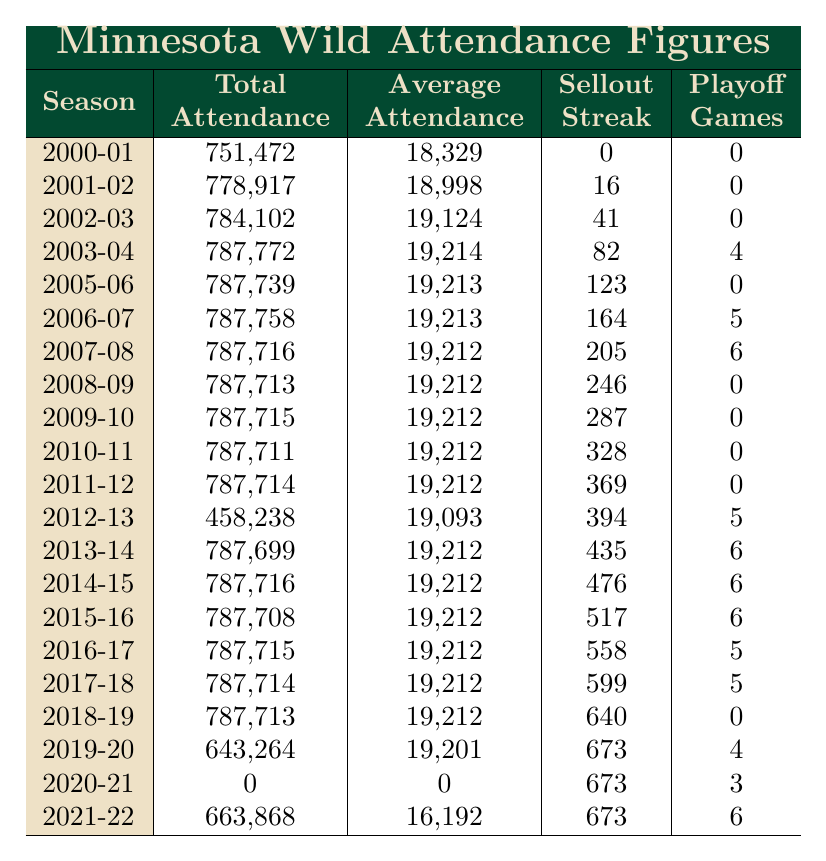What was the total attendance in the 2019-20 season? The table shows that the total attendance for the 2019-20 season was listed as 643,264.
Answer: 643,264 Which season had the highest average attendance? By looking through the Average Attendance column, the highest value is 19,214, which occurred in the seasons: 2003-04, 2005-06, 2006-07, 2007-08, 2008-09, 2009-10, 2010-11, 2011-12, 2013-14, 2014-15, 2015-16, 2016-17, 2017-18, and 2018-19.
Answer: 19,214 Did the Minnesota Wild have any sellout streaks during the 2020-21 season? According to the Sellout Streak column, the value for the 2020-21 season is 673, which indicates a significant sellout streak, but there was actually no attendance due to pandemic restrictions.
Answer: No What is the difference in total attendance between the 2000-01 season and the 2021-22 season? The total attendance for the 2000-01 season is 751,472 and for the 2021-22 season, it is 663,868. The difference is calculated as 751,472 - 663,868 = 87,604.
Answer: 87,604 How many seasons had an average attendance of 19,212? By scanning the Average Attendance column, the value 19,212 appears in the following seasons: 2007-08, 2008-09, 2009-10, 2010-11, 2011-12, 2013-14, 2014-15, 2015-16, 2016-17, 2017-18, and 2018-19. There are 11 seasons in total.
Answer: 11 What was the total attendance for the 2012-13 season, and how does it compare to the previous season? The total attendance for the 2012-13 season is 458,238, and for the 2011-12 season, it is 787,714. The comparison shows a reduction of 329,476.
Answer: 458,238; decreased by 329,476 Was there a drop in attendance during the 2020-21 season compared to the previous season? The attendance in the 2020-21 season is 0, while the attendance in the 2019-20 season was 643,264. Therefore, there was a significant drop.
Answer: Yes What was the average attendance in the 2013-14 season and how does it rank among the other seasons? The average attendance in the 2013-14 season is 19,212. This value ties with several other seasons, placing it among the higher averages but not the highest.
Answer: 19,212 How many playoff games did the Minnesota Wild play in the 2003-04 season? The table clearly shows that the number of playoff games in the 2003-04 season was 4.
Answer: 4 What was the trend in attendance from the 2000-01 season to the 2021-22 season? The total attendance showed an increase initially, peaking around 2011-12, followed by a decline with a significant drop in 2020-21 where attendance was zero due to the pandemic, and a partial recovery in 2021-22.
Answer: Initial increase, peak then decline, zero in 2020-21, partial recovery in 2021-22 